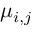<formula> <loc_0><loc_0><loc_500><loc_500>\mu _ { i , j }</formula> 